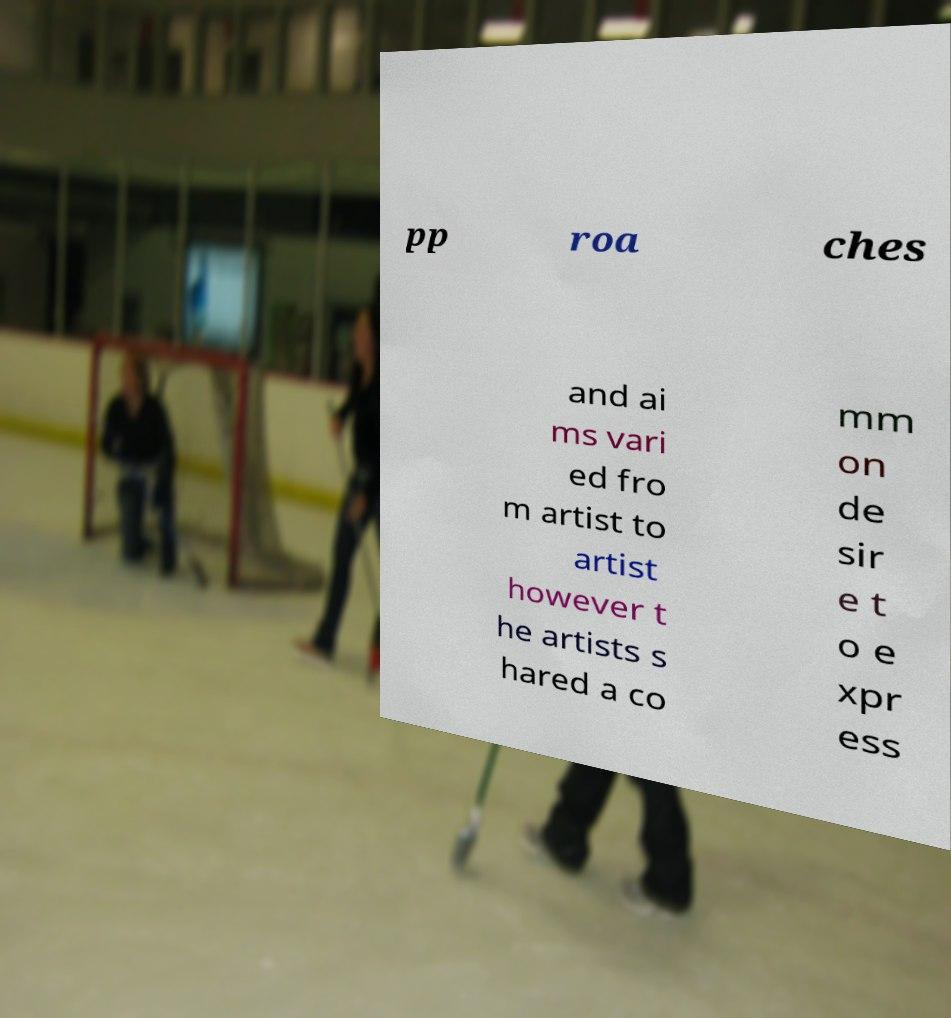Could you extract and type out the text from this image? pp roa ches and ai ms vari ed fro m artist to artist however t he artists s hared a co mm on de sir e t o e xpr ess 